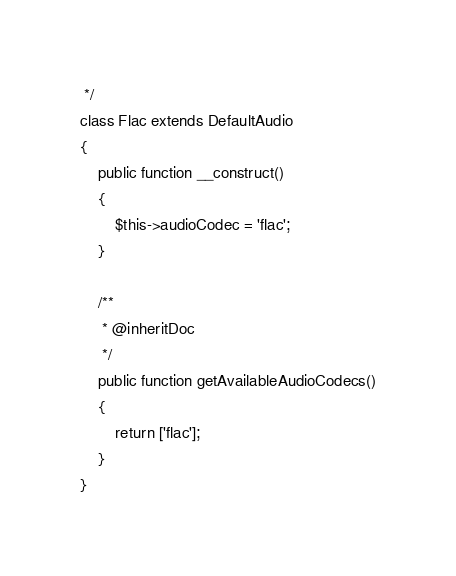<code> <loc_0><loc_0><loc_500><loc_500><_PHP_> */
class Flac extends DefaultAudio
{
    public function __construct()
    {
        $this->audioCodec = 'flac';
    }

    /**
     * @inheritDoc
     */
    public function getAvailableAudioCodecs()
    {
        return ['flac'];
    }
}
</code> 